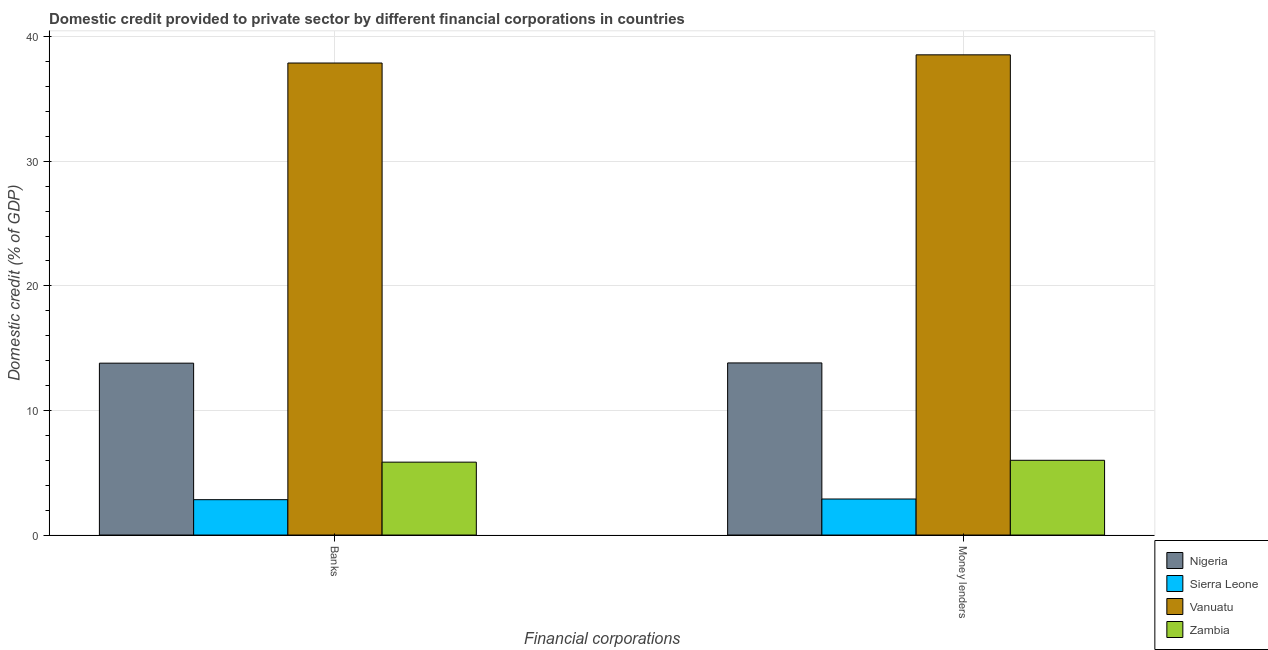How many groups of bars are there?
Keep it short and to the point. 2. Are the number of bars per tick equal to the number of legend labels?
Make the answer very short. Yes. Are the number of bars on each tick of the X-axis equal?
Offer a very short reply. Yes. How many bars are there on the 2nd tick from the left?
Your answer should be very brief. 4. What is the label of the 1st group of bars from the left?
Your answer should be compact. Banks. What is the domestic credit provided by banks in Zambia?
Offer a very short reply. 5.85. Across all countries, what is the maximum domestic credit provided by banks?
Provide a succinct answer. 37.89. Across all countries, what is the minimum domestic credit provided by money lenders?
Provide a succinct answer. 2.89. In which country was the domestic credit provided by money lenders maximum?
Your answer should be very brief. Vanuatu. In which country was the domestic credit provided by banks minimum?
Ensure brevity in your answer.  Sierra Leone. What is the total domestic credit provided by money lenders in the graph?
Give a very brief answer. 61.26. What is the difference between the domestic credit provided by money lenders in Zambia and that in Nigeria?
Make the answer very short. -7.82. What is the difference between the domestic credit provided by banks in Nigeria and the domestic credit provided by money lenders in Vanuatu?
Offer a terse response. -24.75. What is the average domestic credit provided by banks per country?
Your answer should be compact. 15.09. What is the difference between the domestic credit provided by banks and domestic credit provided by money lenders in Sierra Leone?
Provide a short and direct response. -0.05. What is the ratio of the domestic credit provided by money lenders in Nigeria to that in Vanuatu?
Keep it short and to the point. 0.36. In how many countries, is the domestic credit provided by money lenders greater than the average domestic credit provided by money lenders taken over all countries?
Offer a terse response. 1. What does the 2nd bar from the left in Banks represents?
Ensure brevity in your answer.  Sierra Leone. What does the 1st bar from the right in Banks represents?
Offer a very short reply. Zambia. How many countries are there in the graph?
Offer a very short reply. 4. Does the graph contain any zero values?
Give a very brief answer. No. How many legend labels are there?
Provide a short and direct response. 4. What is the title of the graph?
Provide a short and direct response. Domestic credit provided to private sector by different financial corporations in countries. What is the label or title of the X-axis?
Make the answer very short. Financial corporations. What is the label or title of the Y-axis?
Your response must be concise. Domestic credit (% of GDP). What is the Domestic credit (% of GDP) of Nigeria in Banks?
Your answer should be very brief. 13.8. What is the Domestic credit (% of GDP) in Sierra Leone in Banks?
Provide a succinct answer. 2.84. What is the Domestic credit (% of GDP) in Vanuatu in Banks?
Offer a very short reply. 37.89. What is the Domestic credit (% of GDP) of Zambia in Banks?
Offer a very short reply. 5.85. What is the Domestic credit (% of GDP) of Nigeria in Money lenders?
Keep it short and to the point. 13.82. What is the Domestic credit (% of GDP) in Sierra Leone in Money lenders?
Provide a short and direct response. 2.89. What is the Domestic credit (% of GDP) of Vanuatu in Money lenders?
Provide a short and direct response. 38.55. What is the Domestic credit (% of GDP) of Zambia in Money lenders?
Your answer should be compact. 6. Across all Financial corporations, what is the maximum Domestic credit (% of GDP) in Nigeria?
Offer a very short reply. 13.82. Across all Financial corporations, what is the maximum Domestic credit (% of GDP) in Sierra Leone?
Offer a terse response. 2.89. Across all Financial corporations, what is the maximum Domestic credit (% of GDP) of Vanuatu?
Your answer should be very brief. 38.55. Across all Financial corporations, what is the maximum Domestic credit (% of GDP) in Zambia?
Keep it short and to the point. 6. Across all Financial corporations, what is the minimum Domestic credit (% of GDP) of Nigeria?
Your answer should be compact. 13.8. Across all Financial corporations, what is the minimum Domestic credit (% of GDP) in Sierra Leone?
Provide a short and direct response. 2.84. Across all Financial corporations, what is the minimum Domestic credit (% of GDP) of Vanuatu?
Your response must be concise. 37.89. Across all Financial corporations, what is the minimum Domestic credit (% of GDP) in Zambia?
Offer a very short reply. 5.85. What is the total Domestic credit (% of GDP) of Nigeria in the graph?
Your response must be concise. 27.61. What is the total Domestic credit (% of GDP) of Sierra Leone in the graph?
Offer a very short reply. 5.73. What is the total Domestic credit (% of GDP) of Vanuatu in the graph?
Provide a succinct answer. 76.43. What is the total Domestic credit (% of GDP) in Zambia in the graph?
Provide a succinct answer. 11.85. What is the difference between the Domestic credit (% of GDP) of Nigeria in Banks and that in Money lenders?
Your response must be concise. -0.02. What is the difference between the Domestic credit (% of GDP) in Sierra Leone in Banks and that in Money lenders?
Keep it short and to the point. -0.05. What is the difference between the Domestic credit (% of GDP) in Vanuatu in Banks and that in Money lenders?
Offer a very short reply. -0.66. What is the difference between the Domestic credit (% of GDP) of Zambia in Banks and that in Money lenders?
Provide a short and direct response. -0.15. What is the difference between the Domestic credit (% of GDP) in Nigeria in Banks and the Domestic credit (% of GDP) in Sierra Leone in Money lenders?
Your answer should be very brief. 10.9. What is the difference between the Domestic credit (% of GDP) in Nigeria in Banks and the Domestic credit (% of GDP) in Vanuatu in Money lenders?
Keep it short and to the point. -24.75. What is the difference between the Domestic credit (% of GDP) in Nigeria in Banks and the Domestic credit (% of GDP) in Zambia in Money lenders?
Your answer should be compact. 7.8. What is the difference between the Domestic credit (% of GDP) in Sierra Leone in Banks and the Domestic credit (% of GDP) in Vanuatu in Money lenders?
Your answer should be very brief. -35.71. What is the difference between the Domestic credit (% of GDP) of Sierra Leone in Banks and the Domestic credit (% of GDP) of Zambia in Money lenders?
Offer a terse response. -3.16. What is the difference between the Domestic credit (% of GDP) in Vanuatu in Banks and the Domestic credit (% of GDP) in Zambia in Money lenders?
Make the answer very short. 31.89. What is the average Domestic credit (% of GDP) of Nigeria per Financial corporations?
Provide a short and direct response. 13.81. What is the average Domestic credit (% of GDP) of Sierra Leone per Financial corporations?
Keep it short and to the point. 2.87. What is the average Domestic credit (% of GDP) in Vanuatu per Financial corporations?
Keep it short and to the point. 38.22. What is the average Domestic credit (% of GDP) of Zambia per Financial corporations?
Your response must be concise. 5.93. What is the difference between the Domestic credit (% of GDP) in Nigeria and Domestic credit (% of GDP) in Sierra Leone in Banks?
Ensure brevity in your answer.  10.96. What is the difference between the Domestic credit (% of GDP) of Nigeria and Domestic credit (% of GDP) of Vanuatu in Banks?
Give a very brief answer. -24.09. What is the difference between the Domestic credit (% of GDP) of Nigeria and Domestic credit (% of GDP) of Zambia in Banks?
Offer a very short reply. 7.95. What is the difference between the Domestic credit (% of GDP) in Sierra Leone and Domestic credit (% of GDP) in Vanuatu in Banks?
Give a very brief answer. -35.05. What is the difference between the Domestic credit (% of GDP) of Sierra Leone and Domestic credit (% of GDP) of Zambia in Banks?
Ensure brevity in your answer.  -3.01. What is the difference between the Domestic credit (% of GDP) of Vanuatu and Domestic credit (% of GDP) of Zambia in Banks?
Provide a short and direct response. 32.04. What is the difference between the Domestic credit (% of GDP) in Nigeria and Domestic credit (% of GDP) in Sierra Leone in Money lenders?
Offer a terse response. 10.92. What is the difference between the Domestic credit (% of GDP) in Nigeria and Domestic credit (% of GDP) in Vanuatu in Money lenders?
Your answer should be compact. -24.73. What is the difference between the Domestic credit (% of GDP) of Nigeria and Domestic credit (% of GDP) of Zambia in Money lenders?
Your answer should be very brief. 7.82. What is the difference between the Domestic credit (% of GDP) of Sierra Leone and Domestic credit (% of GDP) of Vanuatu in Money lenders?
Offer a terse response. -35.65. What is the difference between the Domestic credit (% of GDP) in Sierra Leone and Domestic credit (% of GDP) in Zambia in Money lenders?
Your answer should be very brief. -3.11. What is the difference between the Domestic credit (% of GDP) in Vanuatu and Domestic credit (% of GDP) in Zambia in Money lenders?
Provide a succinct answer. 32.55. What is the ratio of the Domestic credit (% of GDP) of Sierra Leone in Banks to that in Money lenders?
Offer a very short reply. 0.98. What is the ratio of the Domestic credit (% of GDP) in Vanuatu in Banks to that in Money lenders?
Keep it short and to the point. 0.98. What is the ratio of the Domestic credit (% of GDP) in Zambia in Banks to that in Money lenders?
Offer a terse response. 0.97. What is the difference between the highest and the second highest Domestic credit (% of GDP) in Nigeria?
Your answer should be compact. 0.02. What is the difference between the highest and the second highest Domestic credit (% of GDP) of Sierra Leone?
Provide a short and direct response. 0.05. What is the difference between the highest and the second highest Domestic credit (% of GDP) in Vanuatu?
Ensure brevity in your answer.  0.66. What is the difference between the highest and the second highest Domestic credit (% of GDP) in Zambia?
Provide a short and direct response. 0.15. What is the difference between the highest and the lowest Domestic credit (% of GDP) of Nigeria?
Offer a terse response. 0.02. What is the difference between the highest and the lowest Domestic credit (% of GDP) in Sierra Leone?
Keep it short and to the point. 0.05. What is the difference between the highest and the lowest Domestic credit (% of GDP) of Vanuatu?
Offer a terse response. 0.66. What is the difference between the highest and the lowest Domestic credit (% of GDP) in Zambia?
Offer a terse response. 0.15. 